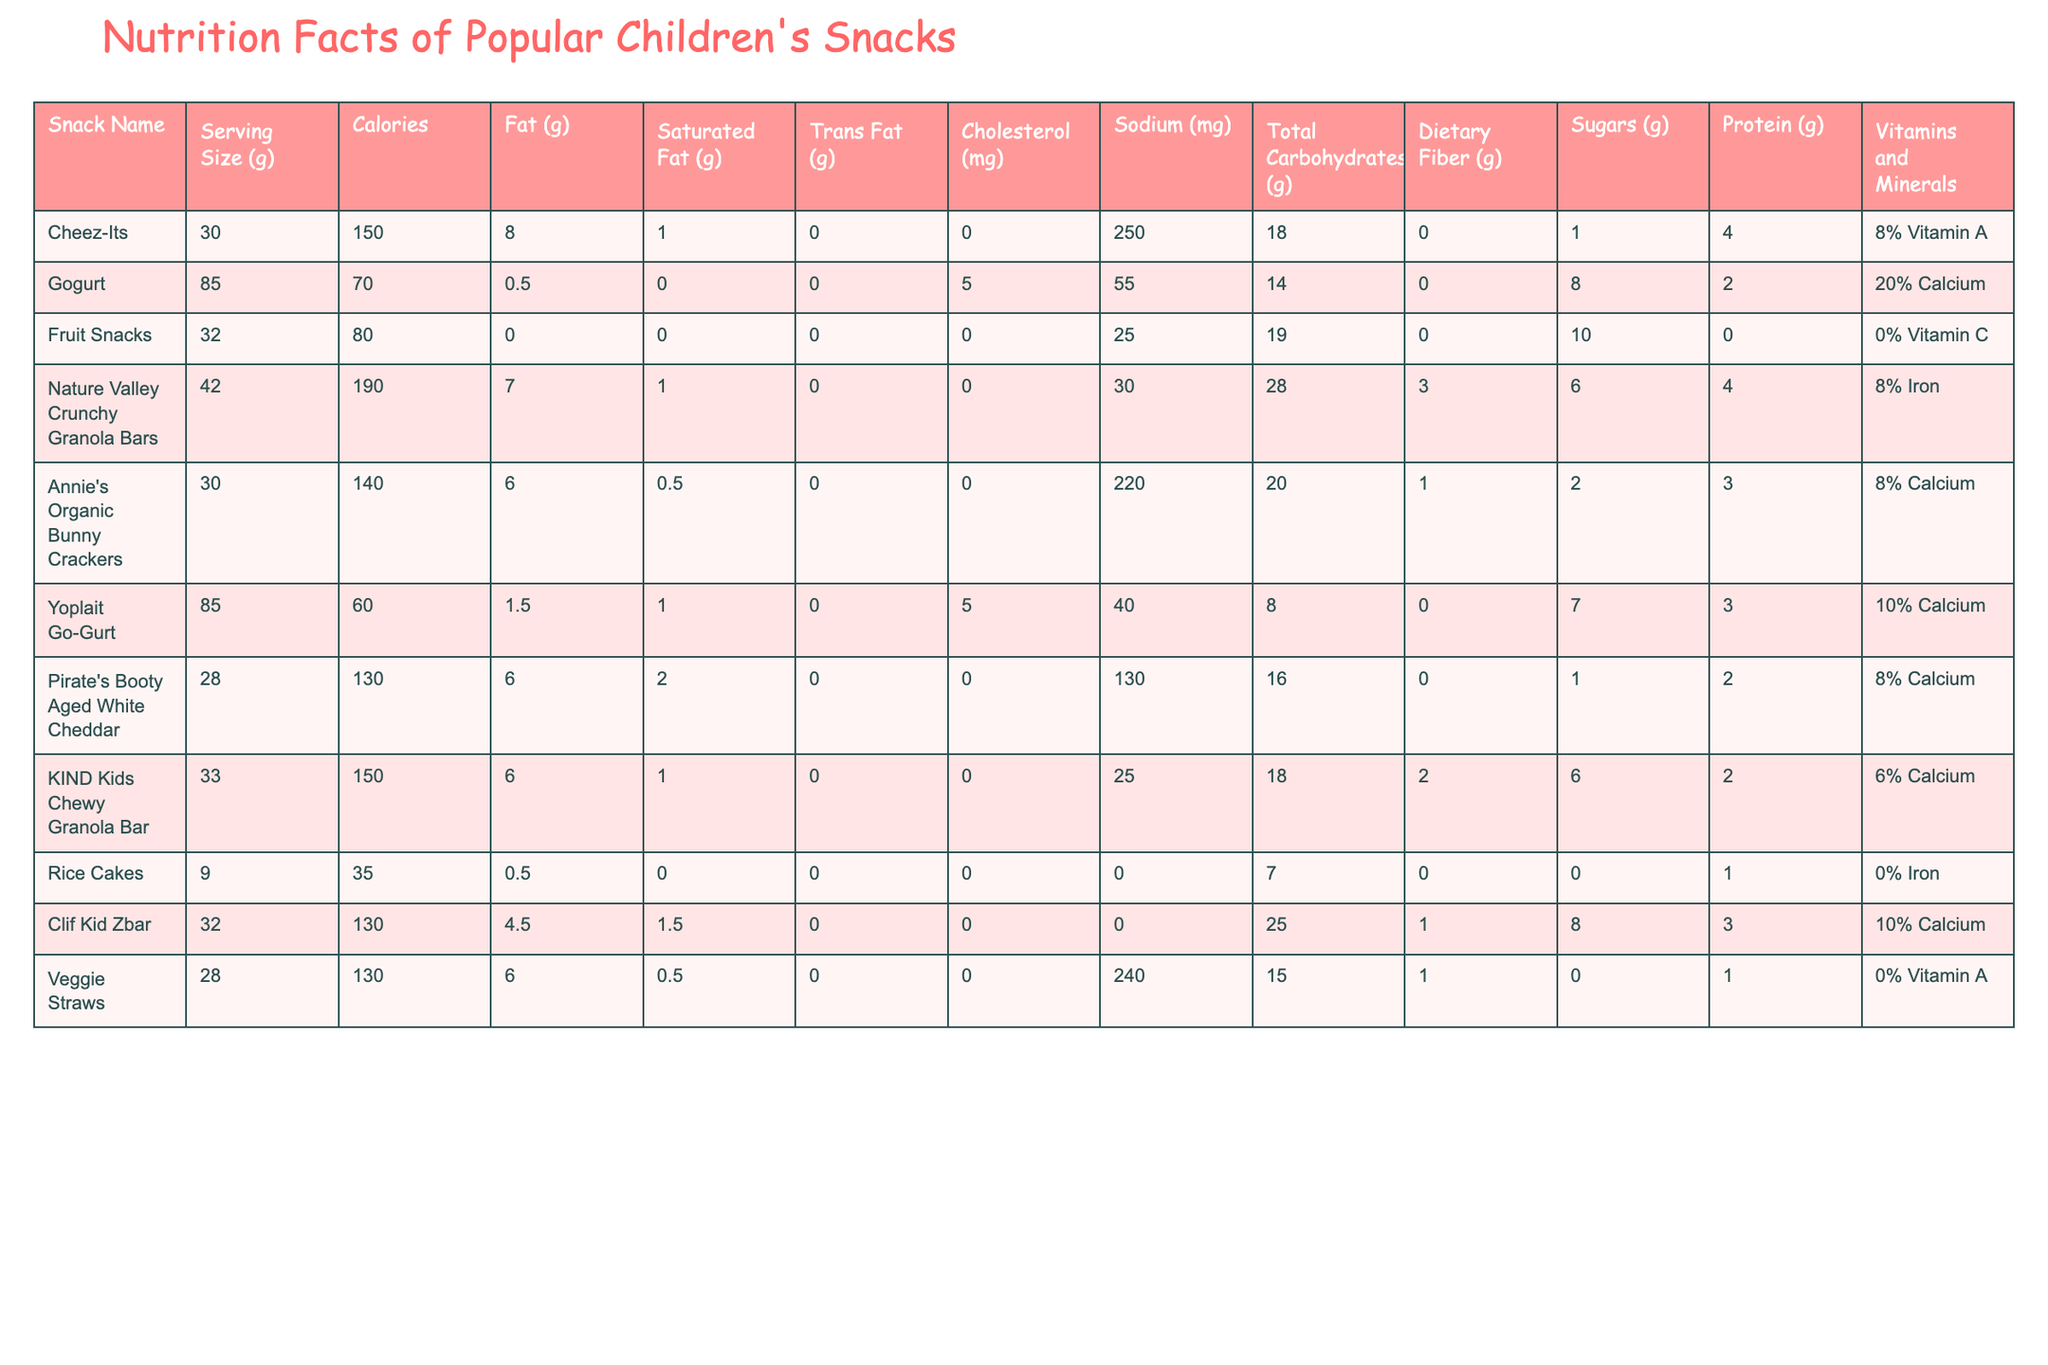What is the calorie content of Cheez-Its? According to the table, the calorie content listed for Cheez-Its is 150 calories per serving.
Answer: 150 calories Which snack has the highest total carbohydrates? By comparing the total carbohydrates column, Nature Valley Crunchy Granola Bars have the highest total carbohydrates at 28g.
Answer: 28g How much saturated fat do Annie's Organic Bunny Crackers contain? The table indicates that Annie's Organic Bunny Crackers contain 0.5g of saturated fat.
Answer: 0.5g Is there any cholesterol in Pirate's Booty Aged White Cheddar? The table shows that Pirate's Booty Aged White Cheddar contains 0mg of cholesterol, indicating that there is none present.
Answer: No What is the average amount of protein in all the snacks listed? First, we will sum the protein content: 4 + 2 + 0 + 4 + 3 + 3 + 2 + 1 + 3 + 2 = 24g. There are 10 snacks, so the average is 24g / 10 = 2.4g.
Answer: 2.4g Which snack has the most sodium? Checking the sodium content for each snack, we find that Veggie Straws contain 240mg, which is the highest amount listed in the table.
Answer: Veggie Straws Do all snacks have dietary fiber listed? The dietary fiber column shows that Rice Cakes have 0g dietary fiber, indicating that not all snacks have this listed.
Answer: No What is the total amount of sugars in Fruit Snacks and Yoplait Go-Gurt combined? Adding the sugars from both snacks gives us 10g (Fruit Snacks) + 7g (Yoplait Go-Gurt) = 17g total sugars.
Answer: 17g Which snack has the lowest calorie content? Upon reviewing the calorie counts, Yoplait Go-Gurt has the lowest calorie count at 60 calories per serving.
Answer: 60 calories How many snacks contain 8% or more of Calcium? By examining the Vitamins and Minerals column, the snacks with 8% or more of calcium are Gogurt, Annie's Organic Bunny Crackers, Clif Kid Zbar, and KIND Kids Chewy Granola Bar. This totals 4 snacks.
Answer: 4 snacks Are there any snacks with Trans Fat? The table lists Trans Fat values, and we can see that Cheez-Its, Nature Valley Crunchy Granola Bars, and Annie's Organic Bunny Crackers have a value of 0g, so there are no snacks with Trans Fat present in this list.
Answer: No 